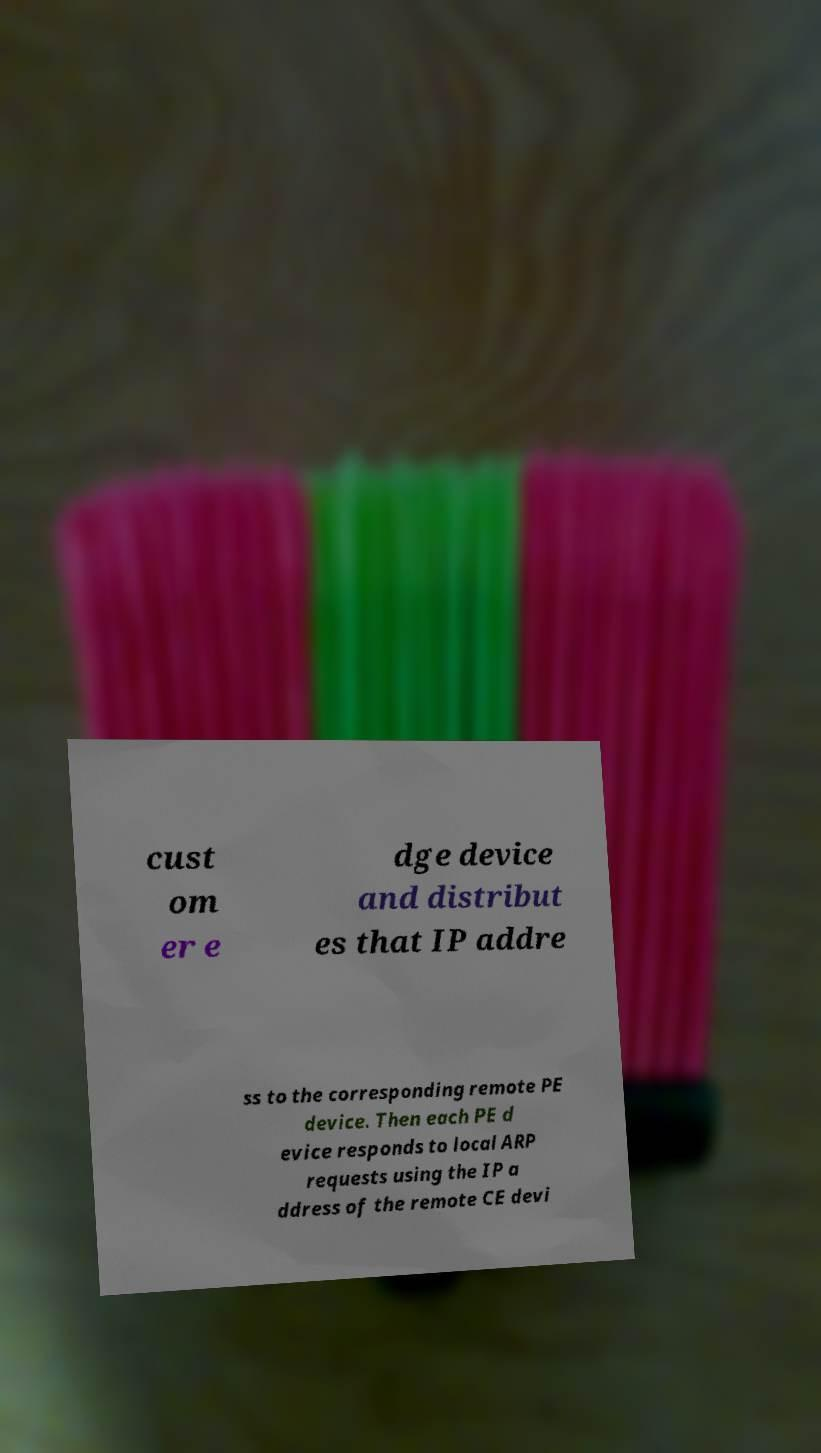Can you read and provide the text displayed in the image?This photo seems to have some interesting text. Can you extract and type it out for me? cust om er e dge device and distribut es that IP addre ss to the corresponding remote PE device. Then each PE d evice responds to local ARP requests using the IP a ddress of the remote CE devi 